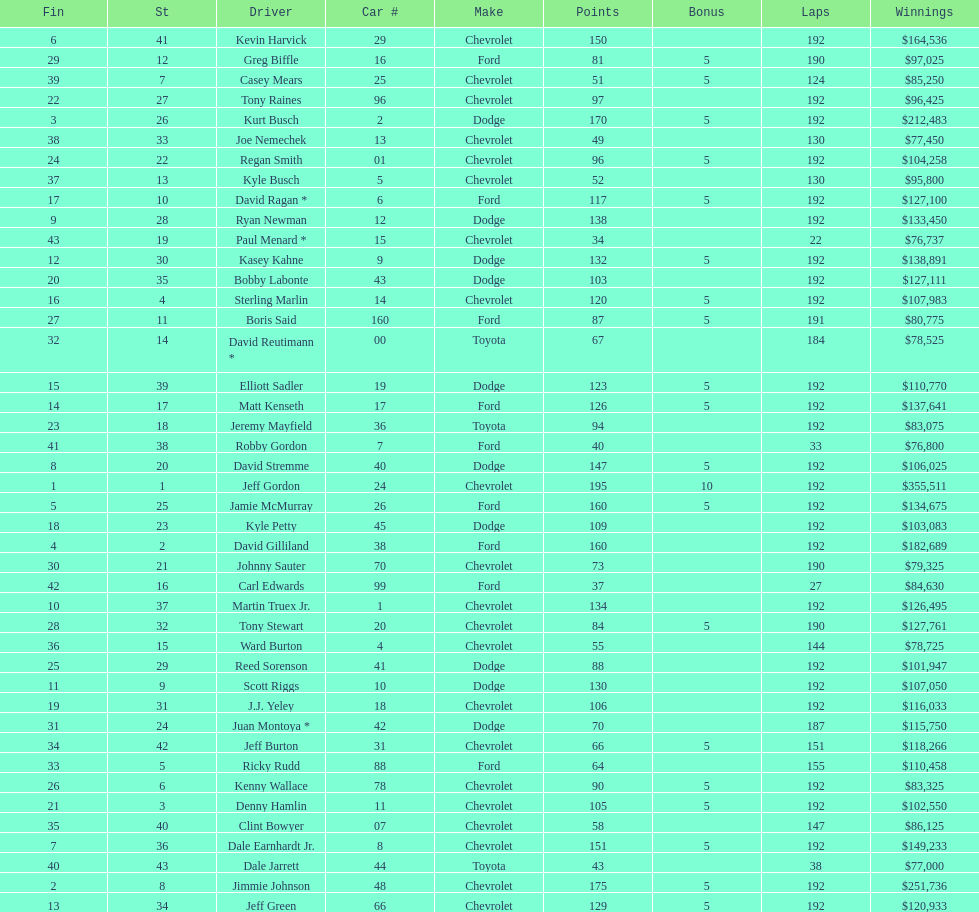Who is first in number of winnings on this list? Jeff Gordon. 